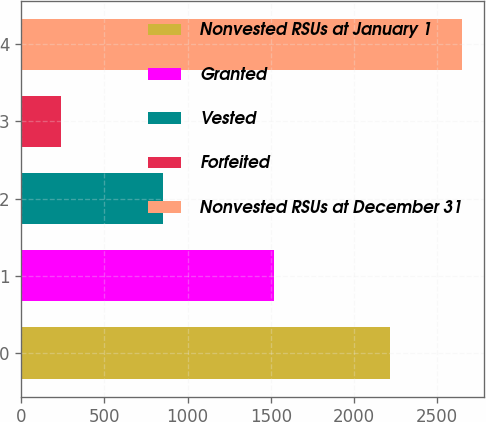Convert chart to OTSL. <chart><loc_0><loc_0><loc_500><loc_500><bar_chart><fcel>Nonvested RSUs at January 1<fcel>Granted<fcel>Vested<fcel>Forfeited<fcel>Nonvested RSUs at December 31<nl><fcel>2218<fcel>1521<fcel>854<fcel>237<fcel>2648<nl></chart> 